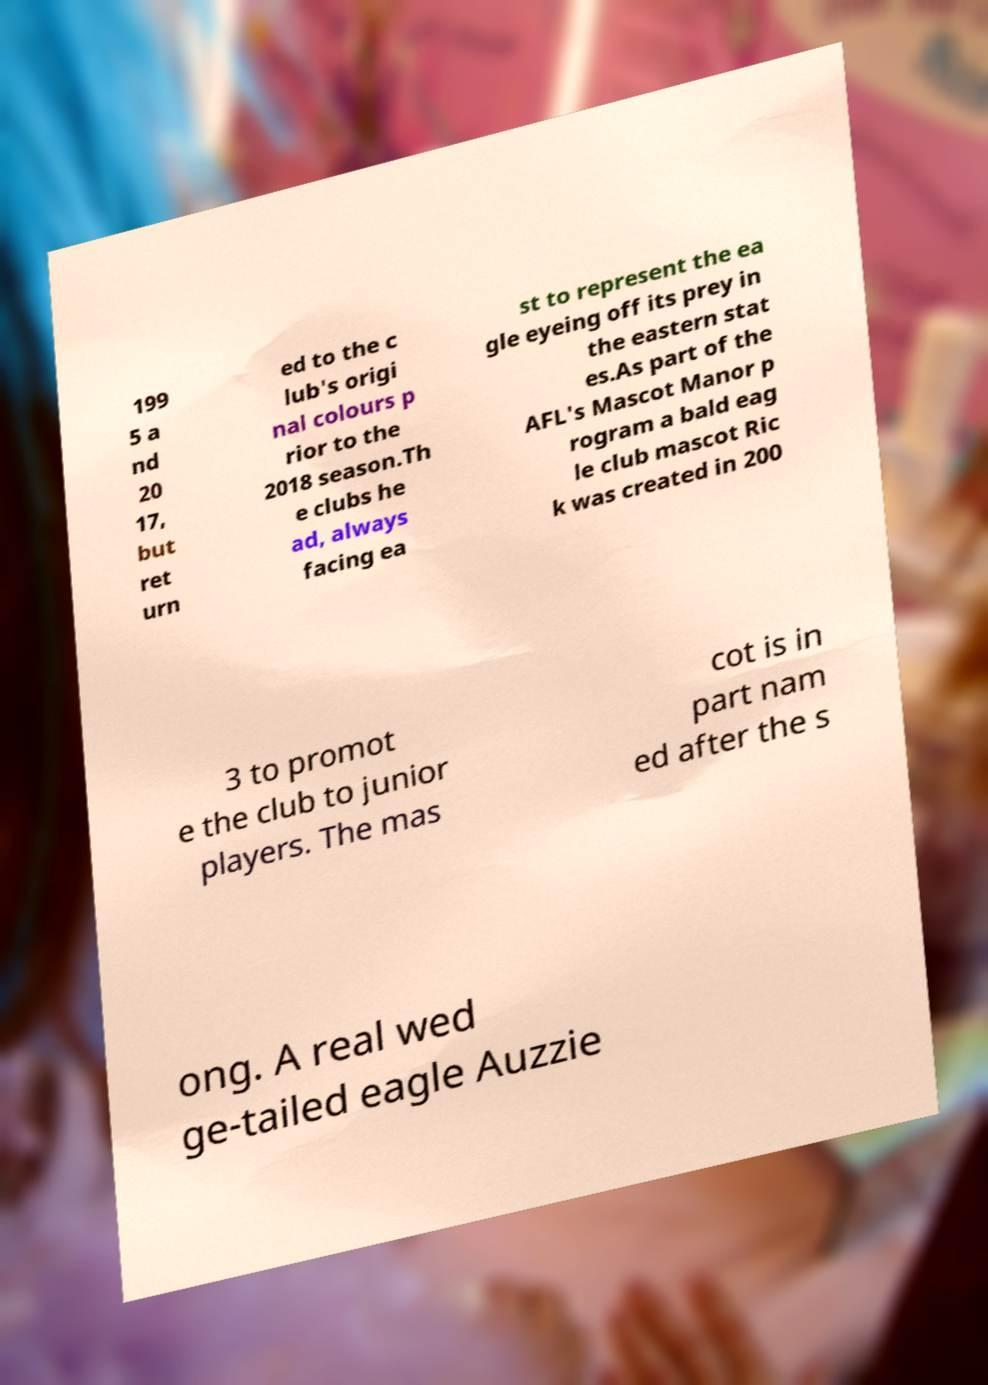I need the written content from this picture converted into text. Can you do that? 199 5 a nd 20 17, but ret urn ed to the c lub's origi nal colours p rior to the 2018 season.Th e clubs he ad, always facing ea st to represent the ea gle eyeing off its prey in the eastern stat es.As part of the AFL's Mascot Manor p rogram a bald eag le club mascot Ric k was created in 200 3 to promot e the club to junior players. The mas cot is in part nam ed after the s ong. A real wed ge-tailed eagle Auzzie 